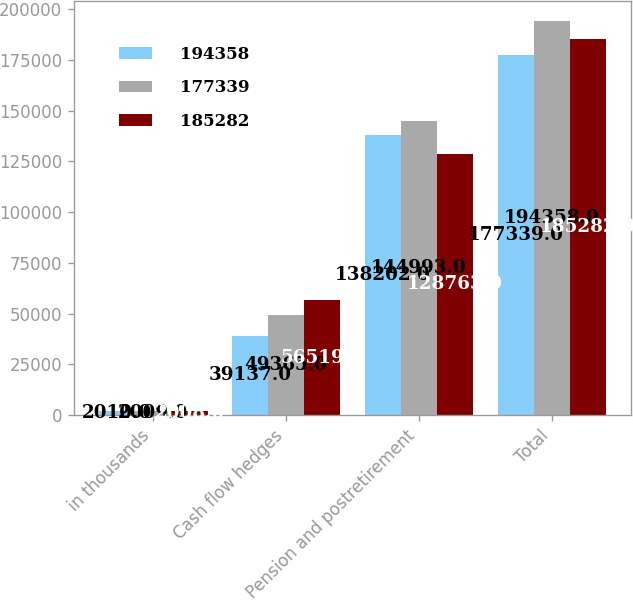Convert chart to OTSL. <chart><loc_0><loc_0><loc_500><loc_500><stacked_bar_chart><ecel><fcel>in thousands<fcel>Cash flow hedges<fcel>Pension and postretirement<fcel>Total<nl><fcel>194358<fcel>2010<fcel>39137<fcel>138202<fcel>177339<nl><fcel>177339<fcel>2009<fcel>49365<fcel>144993<fcel>194358<nl><fcel>185282<fcel>2008<fcel>56519<fcel>128763<fcel>185282<nl></chart> 